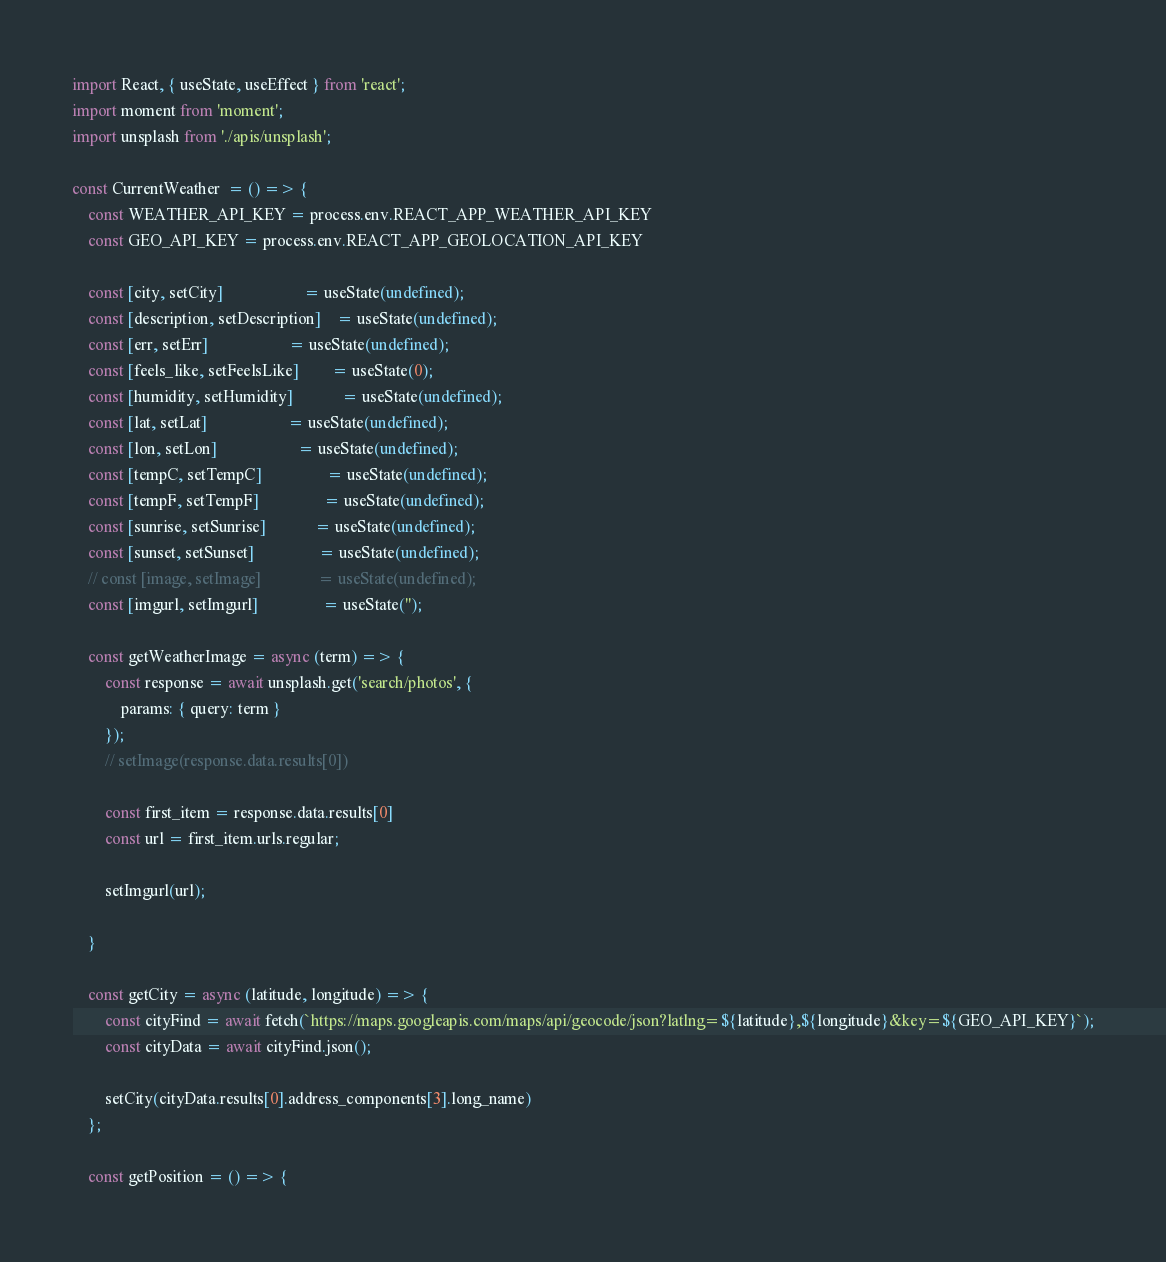Convert code to text. <code><loc_0><loc_0><loc_500><loc_500><_JavaScript_>import React, { useState, useEffect } from 'react';
import moment from 'moment';
import unsplash from './apis/unsplash';

const CurrentWeather  = () => {
	const WEATHER_API_KEY = process.env.REACT_APP_WEATHER_API_KEY
	const GEO_API_KEY = process.env.REACT_APP_GEOLOCATION_API_KEY 

	const [city, setCity] 					= useState(undefined);
	const [description, setDescription] 	= useState(undefined);
	const [err, setErr] 					= useState(undefined);
	const [feels_like, setFeelsLike] 		= useState(0);
	const [humidity, setHumidity] 			= useState(undefined);
	const [lat, setLat] 					= useState(undefined);
	const [lon, setLon] 					= useState(undefined);
	const [tempC, setTempC] 				= useState(undefined);
	const [tempF, setTempF] 				= useState(undefined);
	const [sunrise, setSunrise] 			= useState(undefined);
	const [sunset, setSunset] 				= useState(undefined);
	// const [image, setImage] 				= useState(undefined);
	const [imgurl, setImgurl]				= useState('');

	const getWeatherImage = async (term) => {
		const response = await unsplash.get('search/photos', {
			params: { query: term }
		});
		// setImage(response.data.results[0])

		const first_item = response.data.results[0]
		const url = first_item.urls.regular;

		setImgurl(url);

	}

	const getCity = async (latitude, longitude) => {
		const cityFind = await fetch(`https://maps.googleapis.com/maps/api/geocode/json?latlng=${latitude},${longitude}&key=${GEO_API_KEY}`);
       	const cityData = await cityFind.json();

       	setCity(cityData.results[0].address_components[3].long_name)
	};

	const getPosition = () => {</code> 